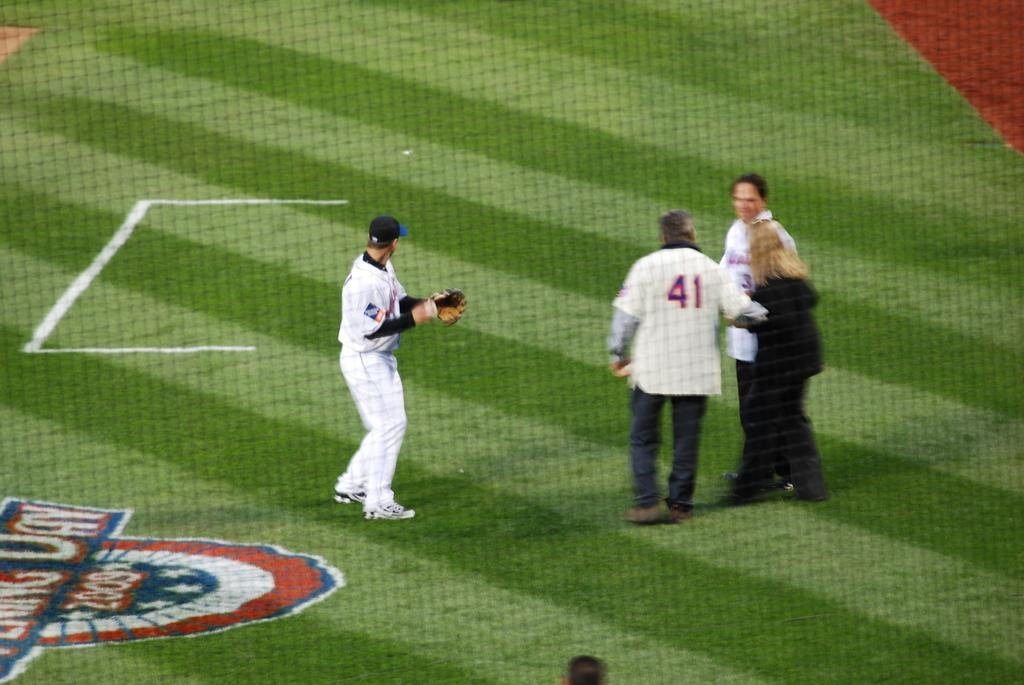What is happening in the image? There are people standing in the image, including a player. Where are the people and player located? They are on grassland, which appears to be a ground. What can be inferred about the activity taking place in the image? The presence of a player suggests that it might be related to a sport or game. What type of apparel are the friends wearing in the image? There is no mention of friends in the provided facts, and therefore we cannot answer a question about their apparel. 